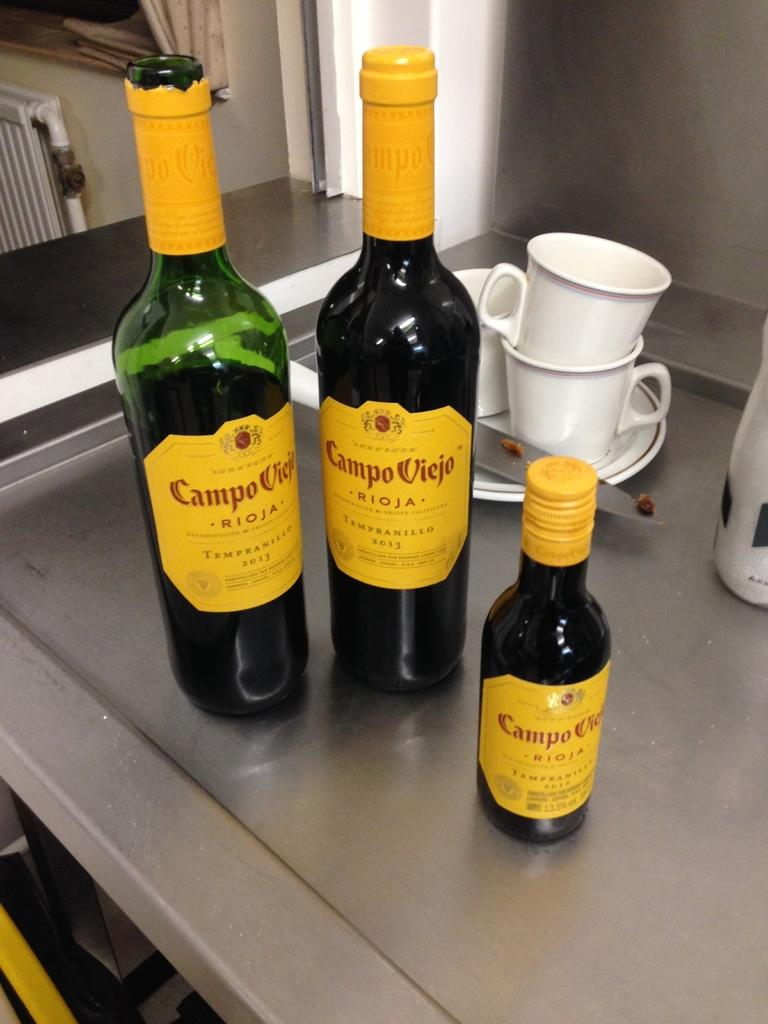<image>
Write a terse but informative summary of the picture. Two bottles of Campo Viejo Rioja sit next to a smaller bottle. 